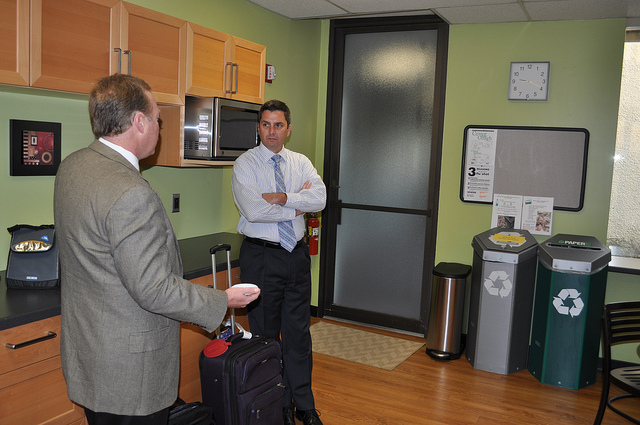Read and extract the text from this image. 3 12 1 2 3 4 5 6 7 8 9 10 